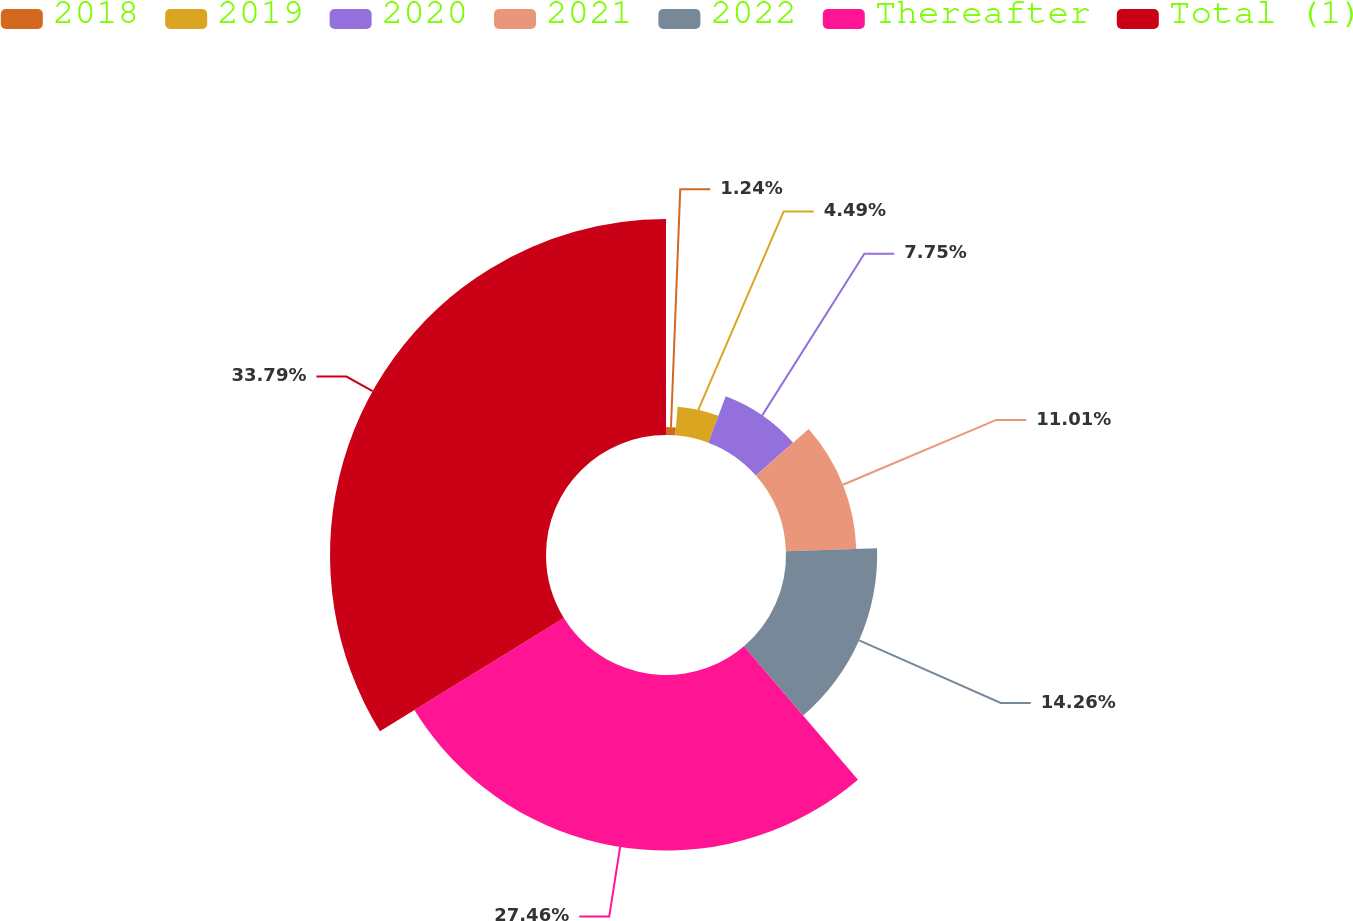<chart> <loc_0><loc_0><loc_500><loc_500><pie_chart><fcel>2018<fcel>2019<fcel>2020<fcel>2021<fcel>2022<fcel>Thereafter<fcel>Total (1)<nl><fcel>1.24%<fcel>4.49%<fcel>7.75%<fcel>11.01%<fcel>14.26%<fcel>27.46%<fcel>33.79%<nl></chart> 